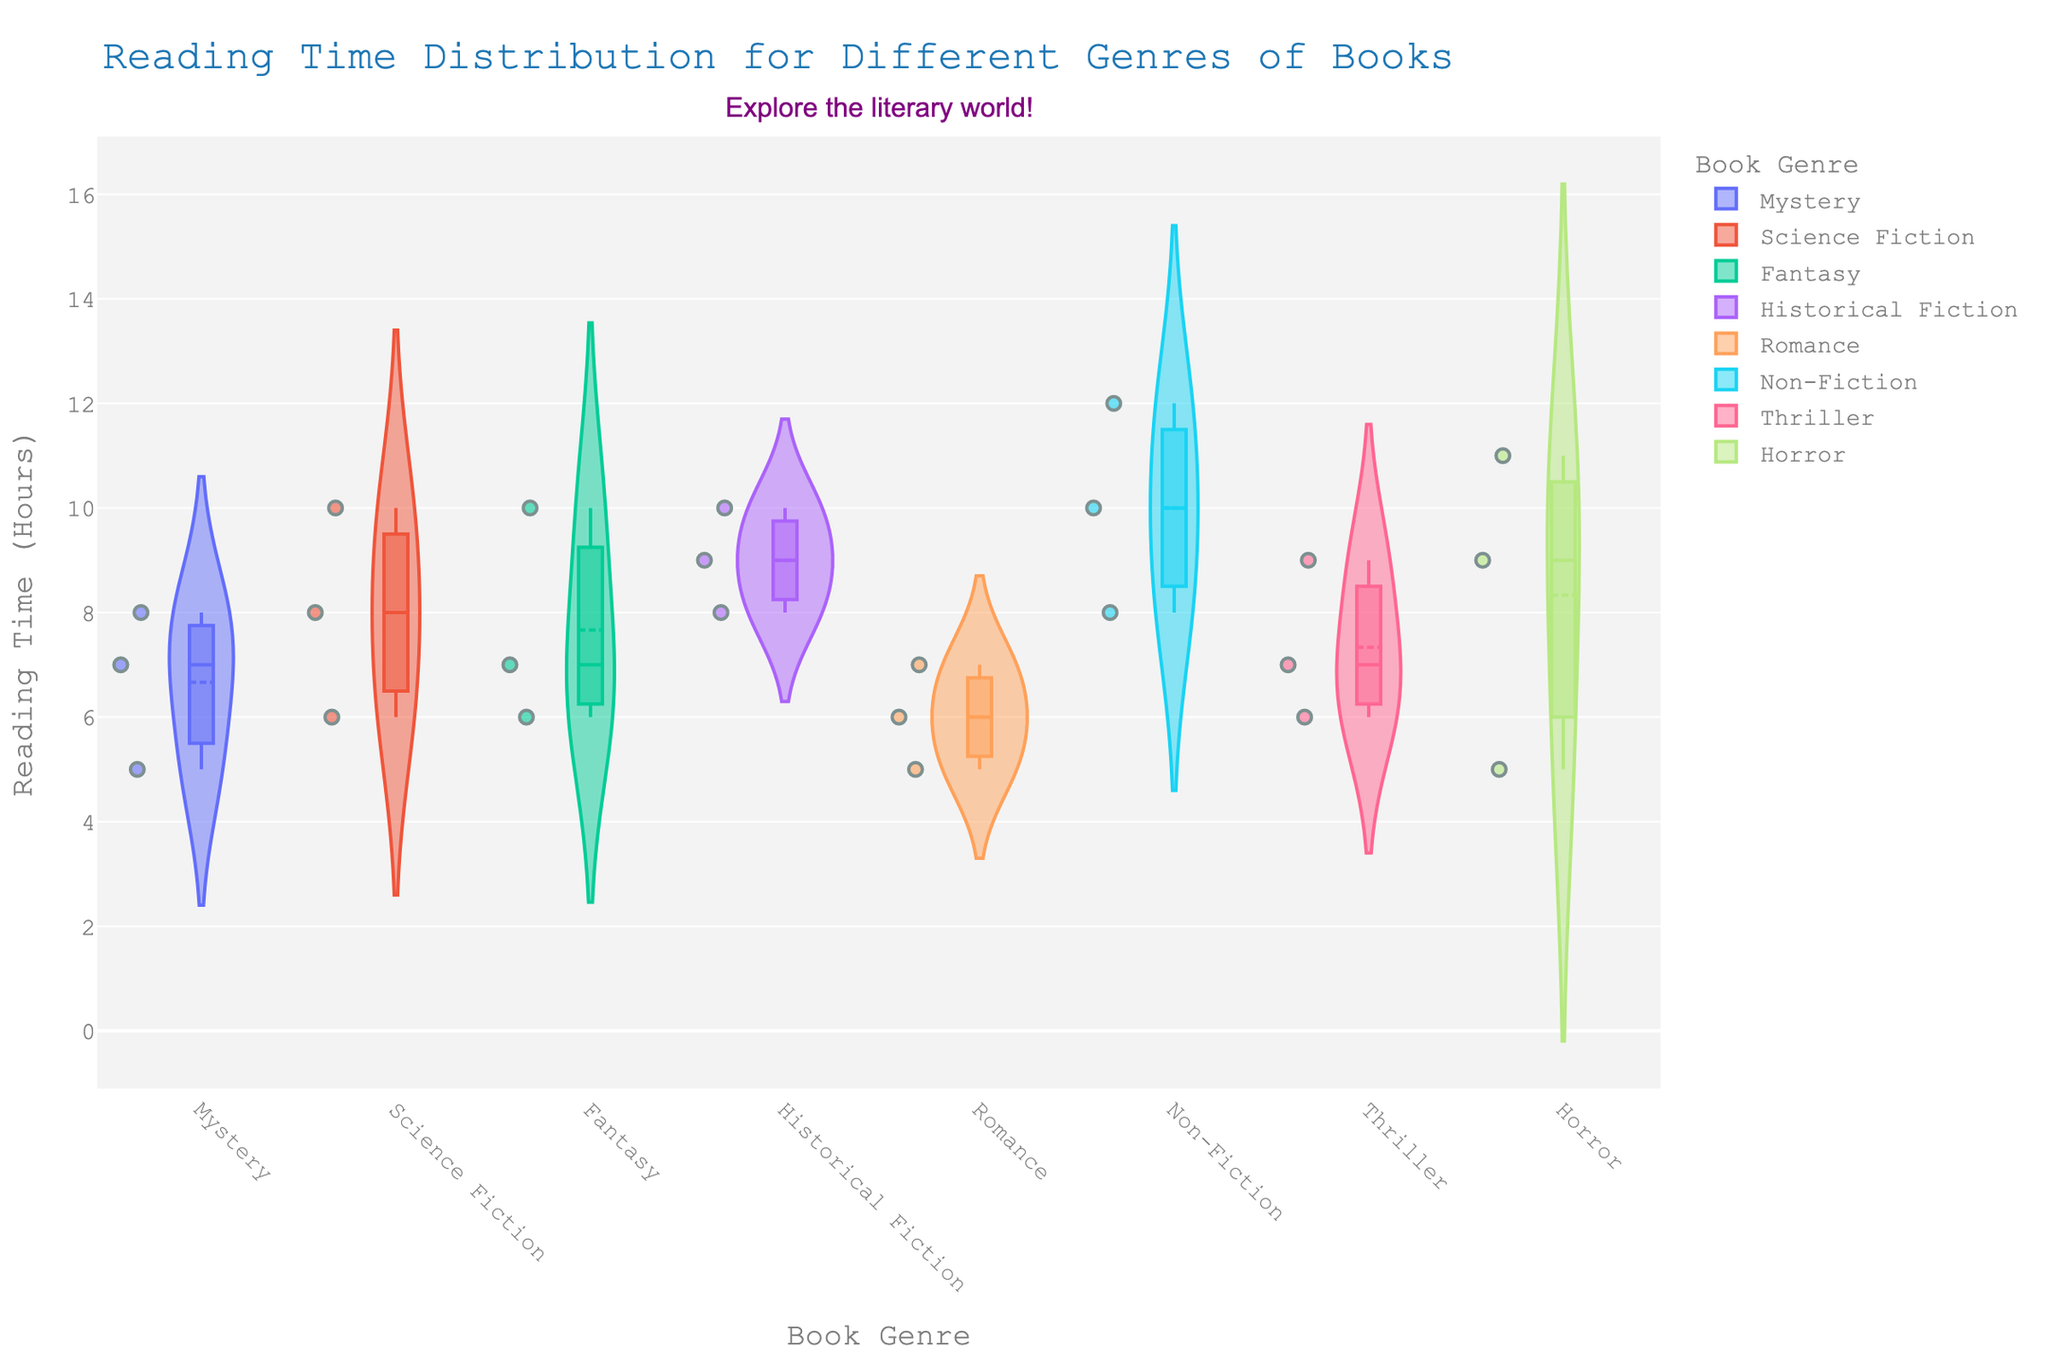What is the title of the figure? The title of the figure is displayed at the top and is labeled "Reading Time Distribution for Different Genres of Books"
Answer: Reading Time Distribution for Different Genres of Books Which book has the highest reading time in the Non-Fiction genre? The Non-Fiction genre's books are shown along the x-axis in the corresponding section. Among them, 'Sapiens' has the highest reading time at 12 hours.
Answer: Sapiens What is the average reading time for the Romance genre? The reading times for Romance are 6, 7, and 5 hours. Calculating the average: (6 + 7 + 5) / 3 = 18 / 3 = 6 hours.
Answer: 6 hours Which genre has the widest spread in reading times? The genre with the widest spread in a violin chart is one that visually extends the most across the y-axis. The Non-Fiction genre ranges from 8 to 12 hours, showing the widest spread.
Answer: Non-Fiction Identify the genre with the lowest median reading time. The median is represented by a horizontal line within each section. The Mystery genre's median lies at 7 hours, but Horror has a median at 9 hours which is higher. Romance shows a median at 6 hours, which is the lowest.
Answer: Romance How many books in the Science Fiction genre have a reading time above the genre's mean? From the data points within the Science Fiction section, the mean line is at 8 hours. Dune has a reading time of 10 hours, which is the only book above the mean.
Answer: 1 Compare the reading times between the Historical Fiction and Fantasy genres. Which has a higher maximum reading time? Observing the maximum points in the Historical Fiction and Fantasy sections, Historical Fiction reaches up to 10 hours, while Fantasy also reaches up to 10 hours. Hence, they have equal maximum reading times.
Answer: Equal Which genre displays the smallest number of data points? Counting the individual data points represented by dots within each genre section indicates that Horror has only three data points.
Answer: Horror What is the interquartile range (IQR) of reading times in the Mystery genre? The IQR is the range between the first and third quartiles in the boxplot. For Mystery, the box’s span indicates an IQR from 6 to 8 hours, thus 8 - 6 = 2 hours.
Answer: 2 hours 